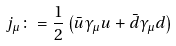Convert formula to latex. <formula><loc_0><loc_0><loc_500><loc_500>j _ { \mu } \colon = \frac { 1 } { 2 } \left ( \bar { u } \gamma _ { \mu } u + \bar { d } \gamma _ { \mu } d \right )</formula> 